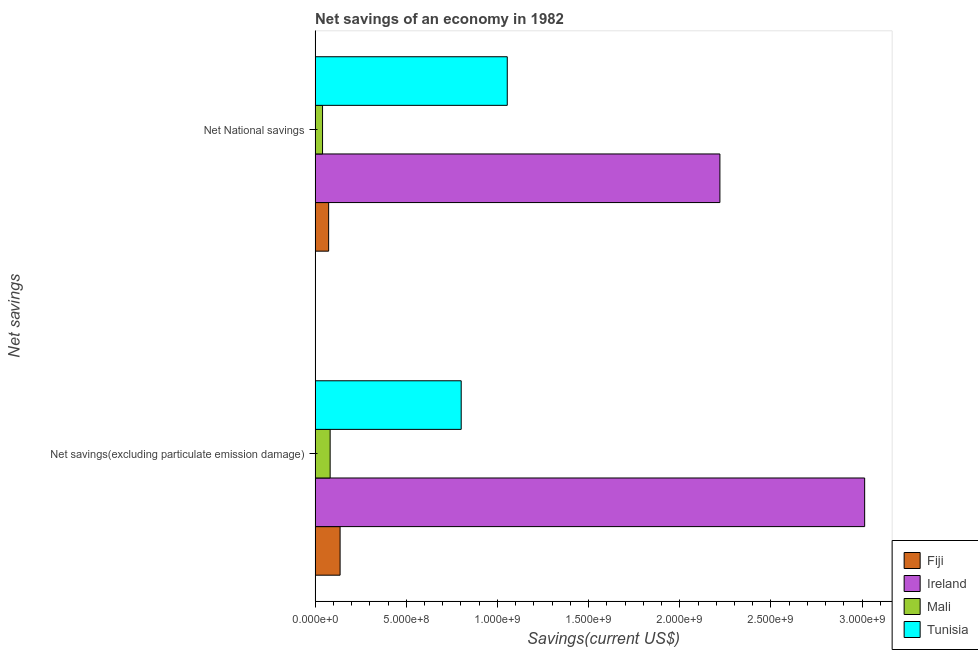How many different coloured bars are there?
Make the answer very short. 4. Are the number of bars on each tick of the Y-axis equal?
Your answer should be compact. Yes. How many bars are there on the 2nd tick from the top?
Provide a short and direct response. 4. How many bars are there on the 2nd tick from the bottom?
Give a very brief answer. 4. What is the label of the 2nd group of bars from the top?
Provide a succinct answer. Net savings(excluding particulate emission damage). What is the net national savings in Tunisia?
Offer a very short reply. 1.05e+09. Across all countries, what is the maximum net savings(excluding particulate emission damage)?
Offer a terse response. 3.01e+09. Across all countries, what is the minimum net national savings?
Keep it short and to the point. 4.08e+07. In which country was the net national savings maximum?
Your answer should be very brief. Ireland. In which country was the net savings(excluding particulate emission damage) minimum?
Your answer should be very brief. Mali. What is the total net savings(excluding particulate emission damage) in the graph?
Offer a very short reply. 4.03e+09. What is the difference between the net savings(excluding particulate emission damage) in Tunisia and that in Fiji?
Ensure brevity in your answer.  6.64e+08. What is the difference between the net national savings in Fiji and the net savings(excluding particulate emission damage) in Mali?
Keep it short and to the point. -8.20e+06. What is the average net savings(excluding particulate emission damage) per country?
Provide a short and direct response. 1.01e+09. What is the difference between the net savings(excluding particulate emission damage) and net national savings in Mali?
Offer a terse response. 4.16e+07. In how many countries, is the net national savings greater than 2900000000 US$?
Keep it short and to the point. 0. What is the ratio of the net savings(excluding particulate emission damage) in Fiji to that in Ireland?
Offer a terse response. 0.05. Is the net savings(excluding particulate emission damage) in Fiji less than that in Tunisia?
Your answer should be very brief. Yes. What does the 4th bar from the top in Net savings(excluding particulate emission damage) represents?
Give a very brief answer. Fiji. What does the 1st bar from the bottom in Net savings(excluding particulate emission damage) represents?
Give a very brief answer. Fiji. How many bars are there?
Provide a short and direct response. 8. Are all the bars in the graph horizontal?
Give a very brief answer. Yes. Are the values on the major ticks of X-axis written in scientific E-notation?
Ensure brevity in your answer.  Yes. Does the graph contain grids?
Make the answer very short. No. How are the legend labels stacked?
Offer a very short reply. Vertical. What is the title of the graph?
Ensure brevity in your answer.  Net savings of an economy in 1982. Does "Cambodia" appear as one of the legend labels in the graph?
Give a very brief answer. No. What is the label or title of the X-axis?
Your answer should be very brief. Savings(current US$). What is the label or title of the Y-axis?
Provide a succinct answer. Net savings. What is the Savings(current US$) of Fiji in Net savings(excluding particulate emission damage)?
Your response must be concise. 1.37e+08. What is the Savings(current US$) of Ireland in Net savings(excluding particulate emission damage)?
Make the answer very short. 3.01e+09. What is the Savings(current US$) of Mali in Net savings(excluding particulate emission damage)?
Provide a succinct answer. 8.25e+07. What is the Savings(current US$) in Tunisia in Net savings(excluding particulate emission damage)?
Ensure brevity in your answer.  8.01e+08. What is the Savings(current US$) of Fiji in Net National savings?
Your response must be concise. 7.43e+07. What is the Savings(current US$) of Ireland in Net National savings?
Provide a short and direct response. 2.22e+09. What is the Savings(current US$) of Mali in Net National savings?
Provide a succinct answer. 4.08e+07. What is the Savings(current US$) in Tunisia in Net National savings?
Offer a terse response. 1.05e+09. Across all Net savings, what is the maximum Savings(current US$) in Fiji?
Provide a succinct answer. 1.37e+08. Across all Net savings, what is the maximum Savings(current US$) of Ireland?
Ensure brevity in your answer.  3.01e+09. Across all Net savings, what is the maximum Savings(current US$) in Mali?
Offer a terse response. 8.25e+07. Across all Net savings, what is the maximum Savings(current US$) of Tunisia?
Make the answer very short. 1.05e+09. Across all Net savings, what is the minimum Savings(current US$) in Fiji?
Your answer should be compact. 7.43e+07. Across all Net savings, what is the minimum Savings(current US$) in Ireland?
Ensure brevity in your answer.  2.22e+09. Across all Net savings, what is the minimum Savings(current US$) of Mali?
Ensure brevity in your answer.  4.08e+07. Across all Net savings, what is the minimum Savings(current US$) in Tunisia?
Ensure brevity in your answer.  8.01e+08. What is the total Savings(current US$) in Fiji in the graph?
Your answer should be compact. 2.11e+08. What is the total Savings(current US$) in Ireland in the graph?
Give a very brief answer. 5.23e+09. What is the total Savings(current US$) in Mali in the graph?
Provide a short and direct response. 1.23e+08. What is the total Savings(current US$) in Tunisia in the graph?
Make the answer very short. 1.85e+09. What is the difference between the Savings(current US$) of Fiji in Net savings(excluding particulate emission damage) and that in Net National savings?
Your answer should be compact. 6.28e+07. What is the difference between the Savings(current US$) of Ireland in Net savings(excluding particulate emission damage) and that in Net National savings?
Your answer should be compact. 7.94e+08. What is the difference between the Savings(current US$) in Mali in Net savings(excluding particulate emission damage) and that in Net National savings?
Keep it short and to the point. 4.16e+07. What is the difference between the Savings(current US$) of Tunisia in Net savings(excluding particulate emission damage) and that in Net National savings?
Your answer should be very brief. -2.53e+08. What is the difference between the Savings(current US$) of Fiji in Net savings(excluding particulate emission damage) and the Savings(current US$) of Ireland in Net National savings?
Ensure brevity in your answer.  -2.08e+09. What is the difference between the Savings(current US$) in Fiji in Net savings(excluding particulate emission damage) and the Savings(current US$) in Mali in Net National savings?
Provide a short and direct response. 9.62e+07. What is the difference between the Savings(current US$) in Fiji in Net savings(excluding particulate emission damage) and the Savings(current US$) in Tunisia in Net National savings?
Provide a short and direct response. -9.17e+08. What is the difference between the Savings(current US$) of Ireland in Net savings(excluding particulate emission damage) and the Savings(current US$) of Mali in Net National savings?
Your answer should be compact. 2.97e+09. What is the difference between the Savings(current US$) of Ireland in Net savings(excluding particulate emission damage) and the Savings(current US$) of Tunisia in Net National savings?
Provide a short and direct response. 1.96e+09. What is the difference between the Savings(current US$) of Mali in Net savings(excluding particulate emission damage) and the Savings(current US$) of Tunisia in Net National savings?
Your answer should be very brief. -9.71e+08. What is the average Savings(current US$) of Fiji per Net savings?
Your answer should be very brief. 1.06e+08. What is the average Savings(current US$) of Ireland per Net savings?
Your response must be concise. 2.62e+09. What is the average Savings(current US$) in Mali per Net savings?
Provide a short and direct response. 6.16e+07. What is the average Savings(current US$) of Tunisia per Net savings?
Provide a succinct answer. 9.27e+08. What is the difference between the Savings(current US$) of Fiji and Savings(current US$) of Ireland in Net savings(excluding particulate emission damage)?
Ensure brevity in your answer.  -2.88e+09. What is the difference between the Savings(current US$) of Fiji and Savings(current US$) of Mali in Net savings(excluding particulate emission damage)?
Make the answer very short. 5.46e+07. What is the difference between the Savings(current US$) in Fiji and Savings(current US$) in Tunisia in Net savings(excluding particulate emission damage)?
Make the answer very short. -6.64e+08. What is the difference between the Savings(current US$) of Ireland and Savings(current US$) of Mali in Net savings(excluding particulate emission damage)?
Provide a short and direct response. 2.93e+09. What is the difference between the Savings(current US$) in Ireland and Savings(current US$) in Tunisia in Net savings(excluding particulate emission damage)?
Offer a very short reply. 2.21e+09. What is the difference between the Savings(current US$) in Mali and Savings(current US$) in Tunisia in Net savings(excluding particulate emission damage)?
Keep it short and to the point. -7.19e+08. What is the difference between the Savings(current US$) in Fiji and Savings(current US$) in Ireland in Net National savings?
Provide a short and direct response. -2.15e+09. What is the difference between the Savings(current US$) in Fiji and Savings(current US$) in Mali in Net National savings?
Provide a short and direct response. 3.35e+07. What is the difference between the Savings(current US$) in Fiji and Savings(current US$) in Tunisia in Net National savings?
Provide a short and direct response. -9.80e+08. What is the difference between the Savings(current US$) of Ireland and Savings(current US$) of Mali in Net National savings?
Your answer should be compact. 2.18e+09. What is the difference between the Savings(current US$) in Ireland and Savings(current US$) in Tunisia in Net National savings?
Your response must be concise. 1.17e+09. What is the difference between the Savings(current US$) in Mali and Savings(current US$) in Tunisia in Net National savings?
Make the answer very short. -1.01e+09. What is the ratio of the Savings(current US$) in Fiji in Net savings(excluding particulate emission damage) to that in Net National savings?
Your answer should be compact. 1.85. What is the ratio of the Savings(current US$) in Ireland in Net savings(excluding particulate emission damage) to that in Net National savings?
Give a very brief answer. 1.36. What is the ratio of the Savings(current US$) of Mali in Net savings(excluding particulate emission damage) to that in Net National savings?
Provide a short and direct response. 2.02. What is the ratio of the Savings(current US$) in Tunisia in Net savings(excluding particulate emission damage) to that in Net National savings?
Provide a short and direct response. 0.76. What is the difference between the highest and the second highest Savings(current US$) of Fiji?
Give a very brief answer. 6.28e+07. What is the difference between the highest and the second highest Savings(current US$) of Ireland?
Keep it short and to the point. 7.94e+08. What is the difference between the highest and the second highest Savings(current US$) of Mali?
Provide a succinct answer. 4.16e+07. What is the difference between the highest and the second highest Savings(current US$) of Tunisia?
Offer a terse response. 2.53e+08. What is the difference between the highest and the lowest Savings(current US$) of Fiji?
Give a very brief answer. 6.28e+07. What is the difference between the highest and the lowest Savings(current US$) of Ireland?
Keep it short and to the point. 7.94e+08. What is the difference between the highest and the lowest Savings(current US$) of Mali?
Make the answer very short. 4.16e+07. What is the difference between the highest and the lowest Savings(current US$) of Tunisia?
Ensure brevity in your answer.  2.53e+08. 